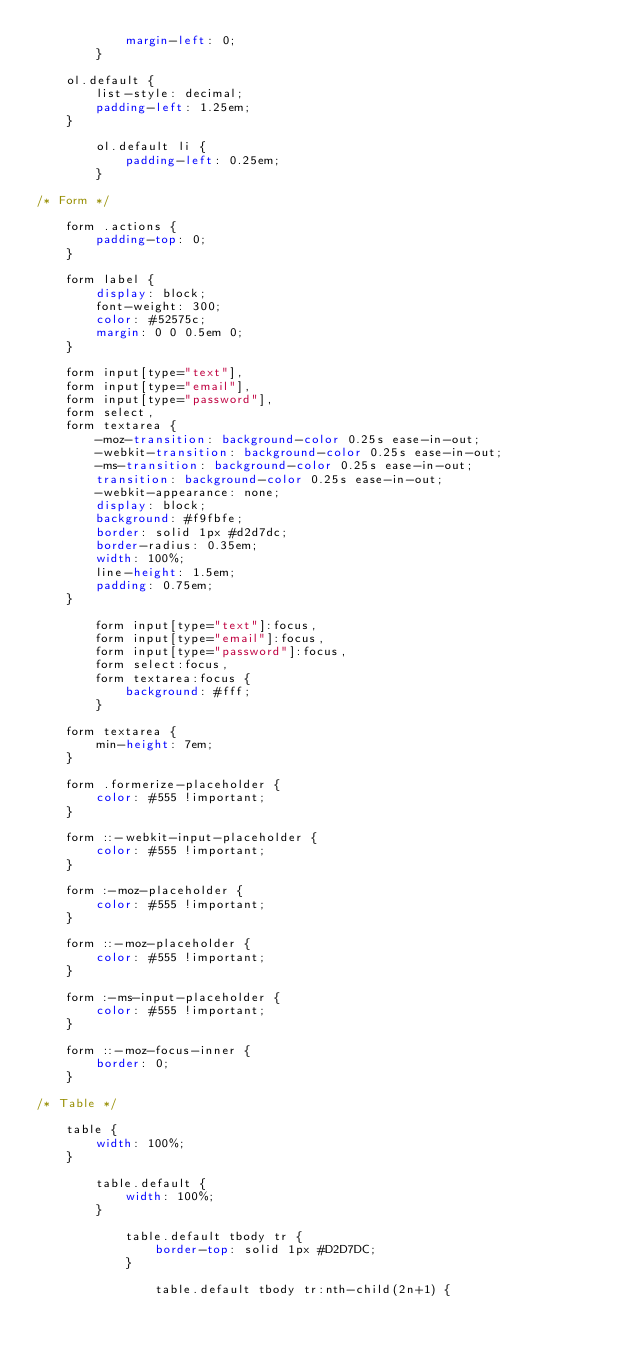Convert code to text. <code><loc_0><loc_0><loc_500><loc_500><_CSS_>			margin-left: 0;
		}

	ol.default {
		list-style: decimal;
		padding-left: 1.25em;
	}

		ol.default li {
			padding-left: 0.25em;
		}

/* Form */

	form .actions {
		padding-top: 0;
	}

	form label {
		display: block;
		font-weight: 300;
		color: #52575c;
		margin: 0 0 0.5em 0;
	}

	form input[type="text"],
	form input[type="email"],
	form input[type="password"],
	form select,
	form textarea {
		-moz-transition: background-color 0.25s ease-in-out;
		-webkit-transition: background-color 0.25s ease-in-out;
		-ms-transition: background-color 0.25s ease-in-out;
		transition: background-color 0.25s ease-in-out;
		-webkit-appearance: none;
		display: block;
		background: #f9fbfe;
		border: solid 1px #d2d7dc;
		border-radius: 0.35em;
		width: 100%;
		line-height: 1.5em;
		padding: 0.75em;
	}

		form input[type="text"]:focus,
		form input[type="email"]:focus,
		form input[type="password"]:focus,
		form select:focus,
		form textarea:focus {
			background: #fff;
		}

	form textarea {
		min-height: 7em;
	}

	form .formerize-placeholder {
		color: #555 !important;
	}

	form ::-webkit-input-placeholder {
		color: #555 !important;
	}

	form :-moz-placeholder {
		color: #555 !important;
	}

	form ::-moz-placeholder {
		color: #555 !important;
	}

	form :-ms-input-placeholder {
		color: #555 !important;
	}

	form ::-moz-focus-inner {
		border: 0;
	}

/* Table */

	table {
		width: 100%;
	}

		table.default {
			width: 100%;
		}

			table.default tbody tr {
				border-top: solid 1px #D2D7DC;
			}

				table.default tbody tr:nth-child(2n+1) {</code> 